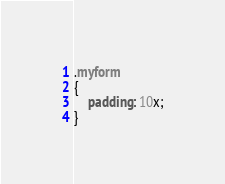<code> <loc_0><loc_0><loc_500><loc_500><_CSS_>.myform
{
    padding: 10x;
}</code> 